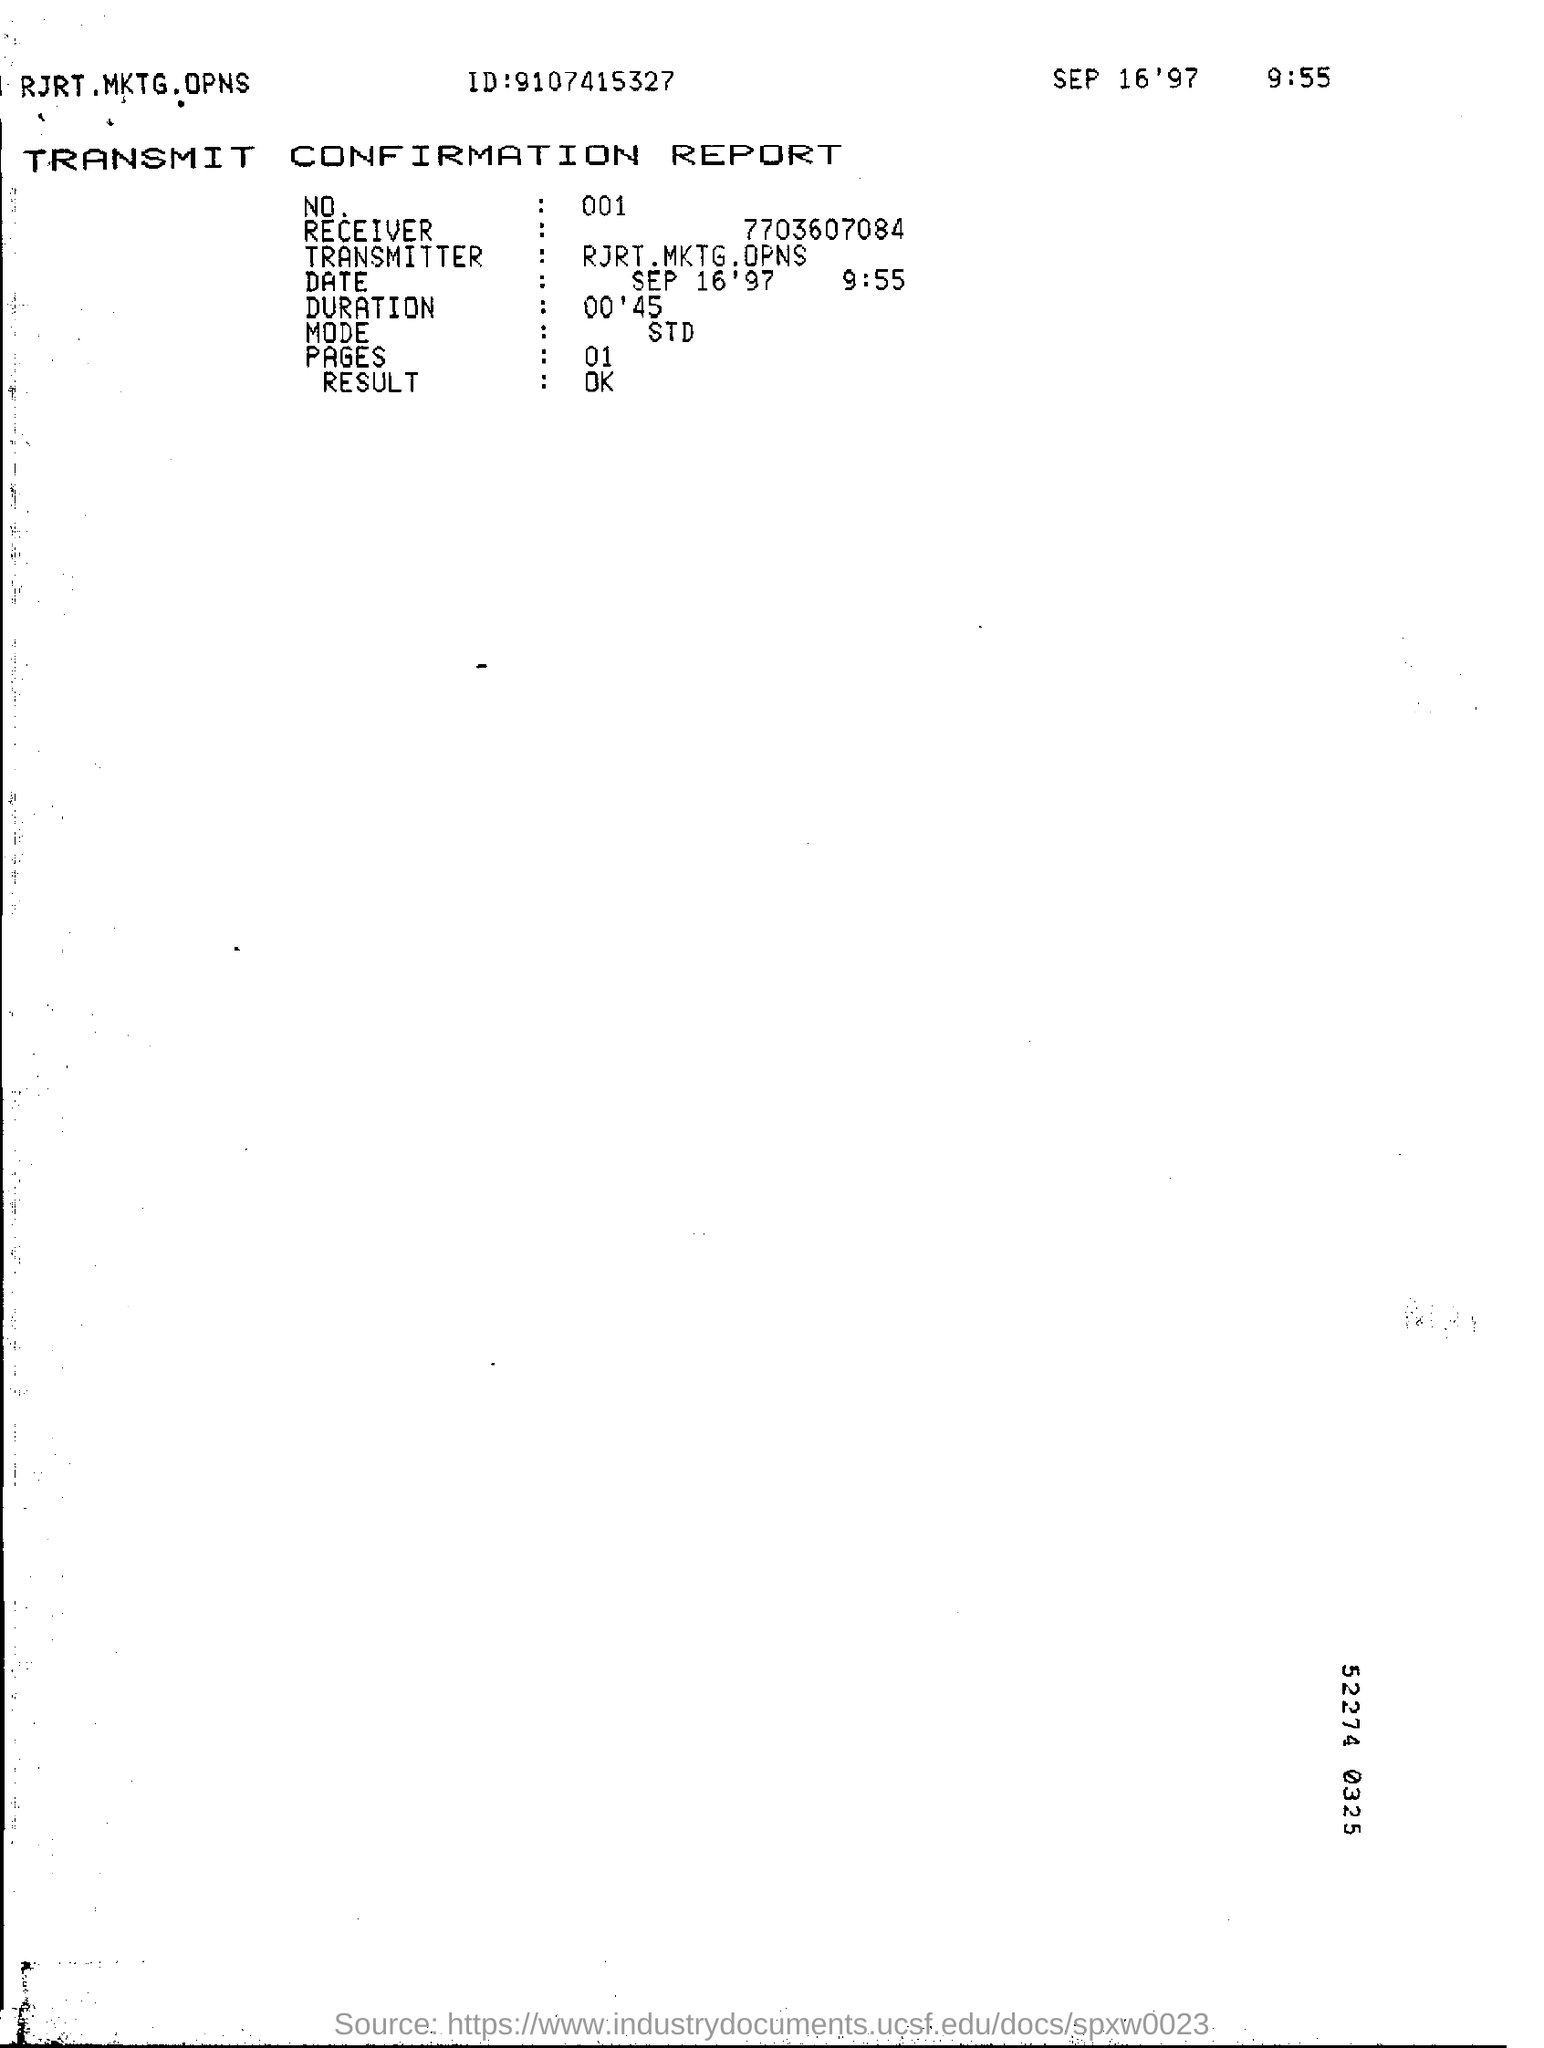What is the mode of the report?
Give a very brief answer. STD. What is the duration mentioned on the report?
Your response must be concise. 00'45. How many number of pages does the report include?
Keep it short and to the point. 01. 